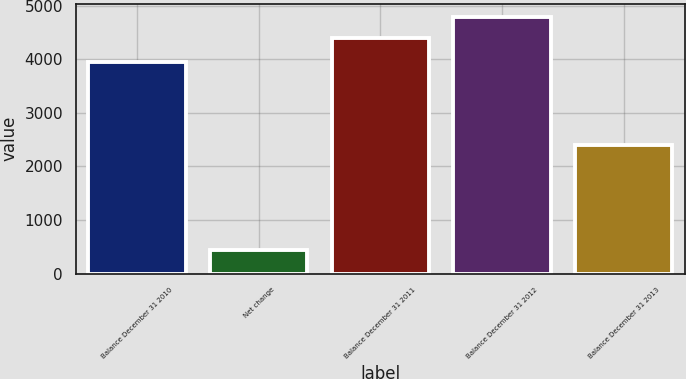Convert chart. <chart><loc_0><loc_0><loc_500><loc_500><bar_chart><fcel>Balance December 31 2010<fcel>Net change<fcel>Balance December 31 2011<fcel>Balance December 31 2012<fcel>Balance December 31 2013<nl><fcel>3947<fcel>444<fcel>4391<fcel>4792.2<fcel>2407<nl></chart> 